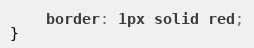Convert code to text. <code><loc_0><loc_0><loc_500><loc_500><_CSS_>    border: 1px solid red;
}</code> 